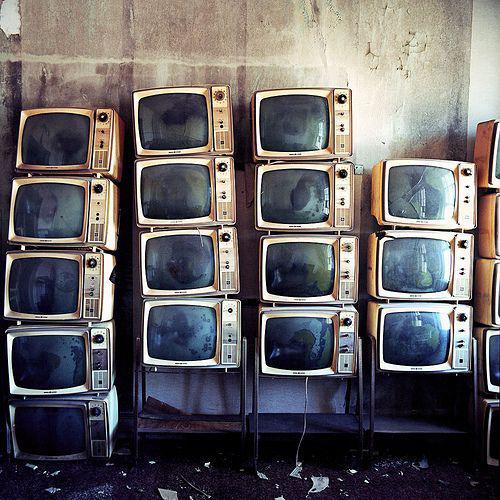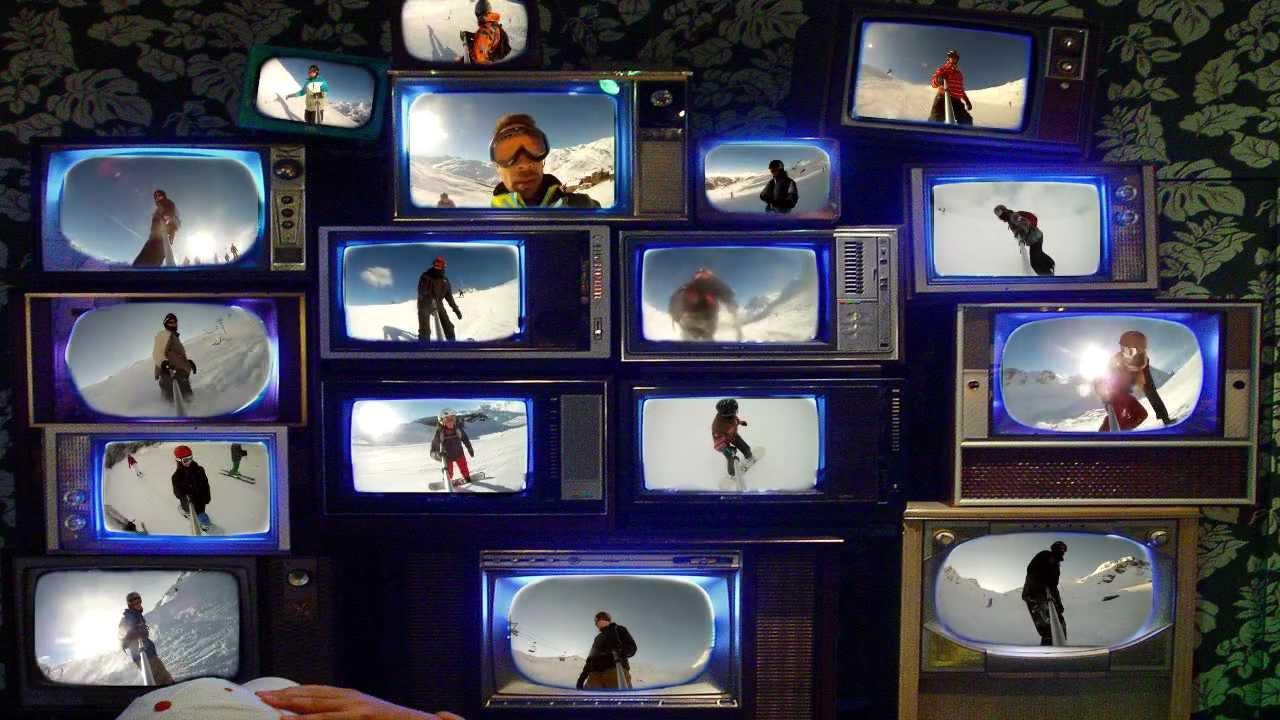The first image is the image on the left, the second image is the image on the right. Considering the images on both sides, is "The televisions in the image on the right are all turned on." valid? Answer yes or no. Yes. 